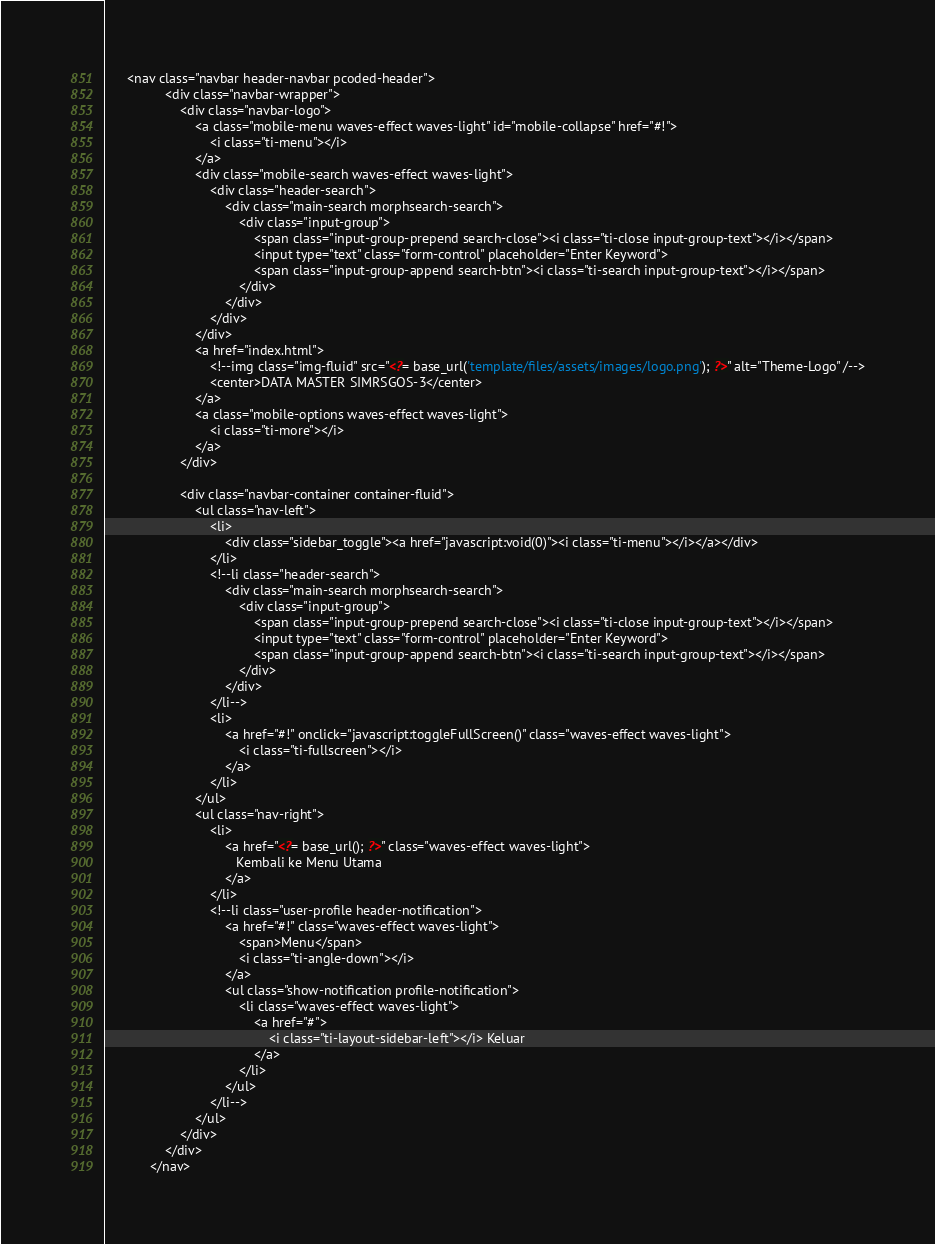<code> <loc_0><loc_0><loc_500><loc_500><_PHP_>      <nav class="navbar header-navbar pcoded-header">
                <div class="navbar-wrapper">
                    <div class="navbar-logo">
                        <a class="mobile-menu waves-effect waves-light" id="mobile-collapse" href="#!">
                            <i class="ti-menu"></i>
                        </a>
                        <div class="mobile-search waves-effect waves-light">
                            <div class="header-search">
                                <div class="main-search morphsearch-search">
                                    <div class="input-group">
                                        <span class="input-group-prepend search-close"><i class="ti-close input-group-text"></i></span>
                                        <input type="text" class="form-control" placeholder="Enter Keyword">
                                        <span class="input-group-append search-btn"><i class="ti-search input-group-text"></i></span>
                                    </div>
                                </div>
                            </div>
                        </div>
                        <a href="index.html">
                            <!--img class="img-fluid" src="<?= base_url('template/files/assets/images/logo.png'); ?>" alt="Theme-Logo" /-->
                            <center>DATA MASTER SIMRSGOS-3</center>
                        </a>
                        <a class="mobile-options waves-effect waves-light">
                            <i class="ti-more"></i>
                        </a>
                    </div>
                    
                    <div class="navbar-container container-fluid">
                        <ul class="nav-left">
                            <li>
                                <div class="sidebar_toggle"><a href="javascript:void(0)"><i class="ti-menu"></i></a></div>
                            </li>
                            <!--li class="header-search">
                                <div class="main-search morphsearch-search">
                                    <div class="input-group">
                                        <span class="input-group-prepend search-close"><i class="ti-close input-group-text"></i></span>
                                        <input type="text" class="form-control" placeholder="Enter Keyword">
                                        <span class="input-group-append search-btn"><i class="ti-search input-group-text"></i></span>
                                    </div>
                                </div>
                            </li-->
                            <li>
                                <a href="#!" onclick="javascript:toggleFullScreen()" class="waves-effect waves-light">
                                    <i class="ti-fullscreen"></i>
                                </a>
                            </li>
                        </ul>
                        <ul class="nav-right">
                            <li>
                                <a href="<?= base_url(); ?>" class="waves-effect waves-light">
                                   Kembali ke Menu Utama
                                </a>
                            </li>
                            <!--li class="user-profile header-notification">
                                <a href="#!" class="waves-effect waves-light">
                                    <span>Menu</span>
                                    <i class="ti-angle-down"></i>
                                </a>
                                <ul class="show-notification profile-notification">
                                    <li class="waves-effect waves-light">
                                        <a href="#">
                                            <i class="ti-layout-sidebar-left"></i> Keluar
                                        </a>
                                    </li>
                                </ul>
                            </li-->
                        </ul>
                    </div>
                </div>
            </nav></code> 